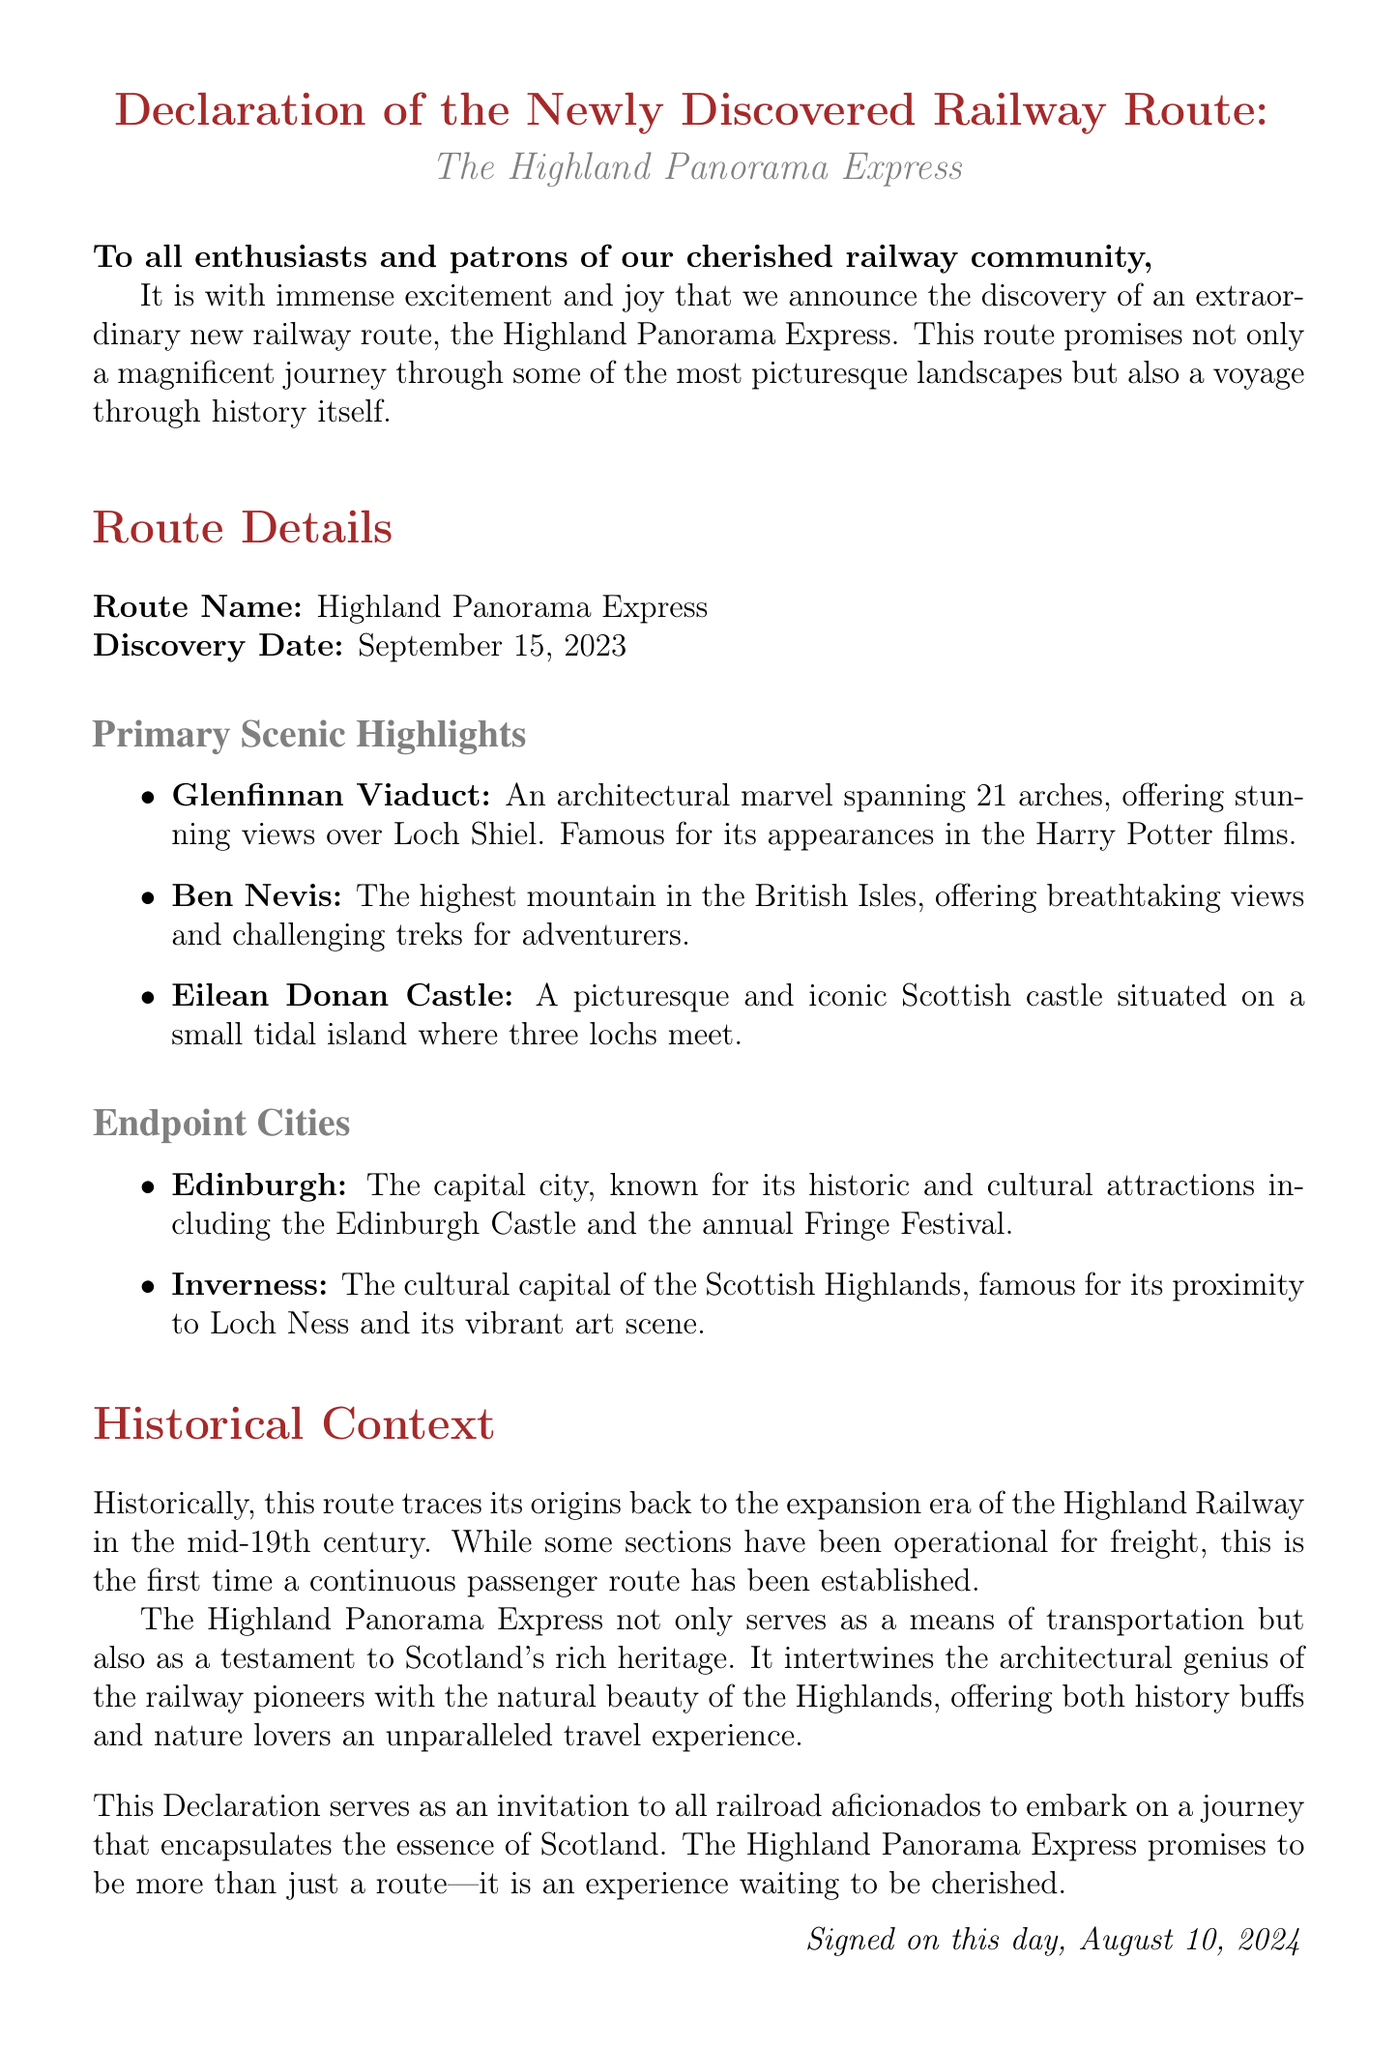What is the name of the new railway route? The document explicitly states the name of the new railway route is the Highland Panorama Express.
Answer: Highland Panorama Express When was the railway route discovered? The document provides the discovery date of the railway route as September 15, 2023.
Answer: September 15, 2023 What is the highest mountain along the route? The document mentions Ben Nevis as the highest mountain in the British Isles along this route.
Answer: Ben Nevis Which castle is highlighted as a scenic point? The document lists Eilean Donan Castle as one of the primary scenic highlights of the route.
Answer: Eilean Donan Castle What two endpoint cities are mentioned? The document names Edinburgh and Inverness as the endpoint cities for the Highland Panorama Express.
Answer: Edinburgh, Inverness What type of heritage does the route embody? The document describes the Highland Panorama Express as a testament to Scotland's rich heritage.
Answer: Scotland's rich heritage Which famous film features the Glenfinnan Viaduct? The document references the Harry Potter films as featuring the Glenfinnan Viaduct.
Answer: Harry Potter What era does the historical context trace back to? The document states that the historical context traces back to the mid-19th century during the expansion era of the Highland Railway.
Answer: mid-19th century 